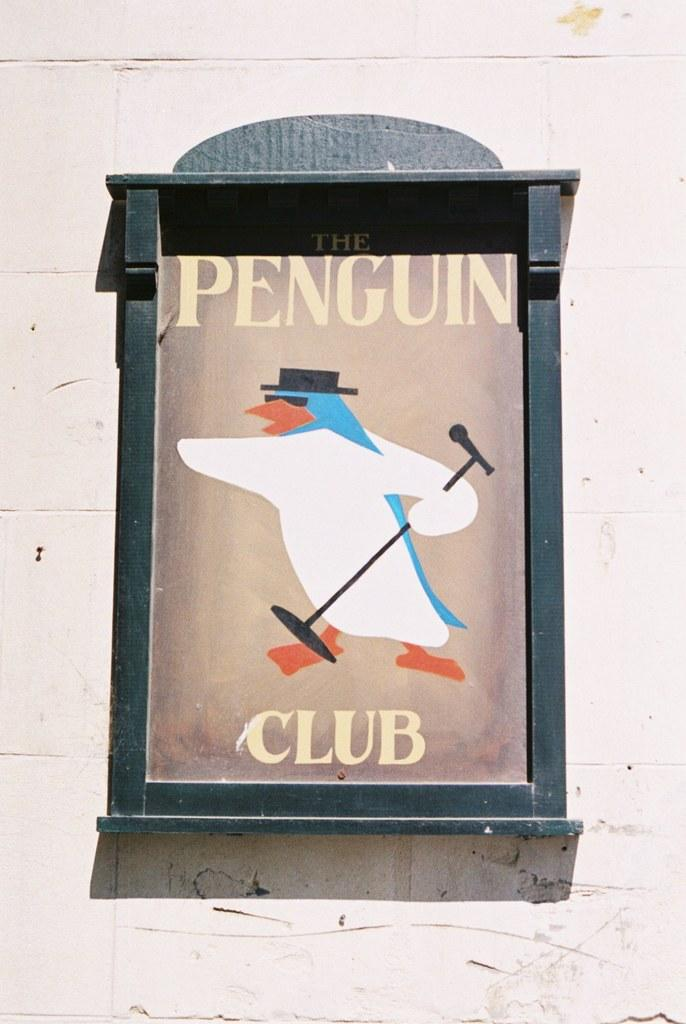What is attached to the wall in the image? There is a frame attached to a wall in the image. What is inside the frame? There is an image within the frame. Can you describe any text visible in the image? Yes, there is some text visible in the image. What type of rod can be seen holding up the sand in the image? There is no rod or sand present in the image; it only features a frame with an image and some text. 